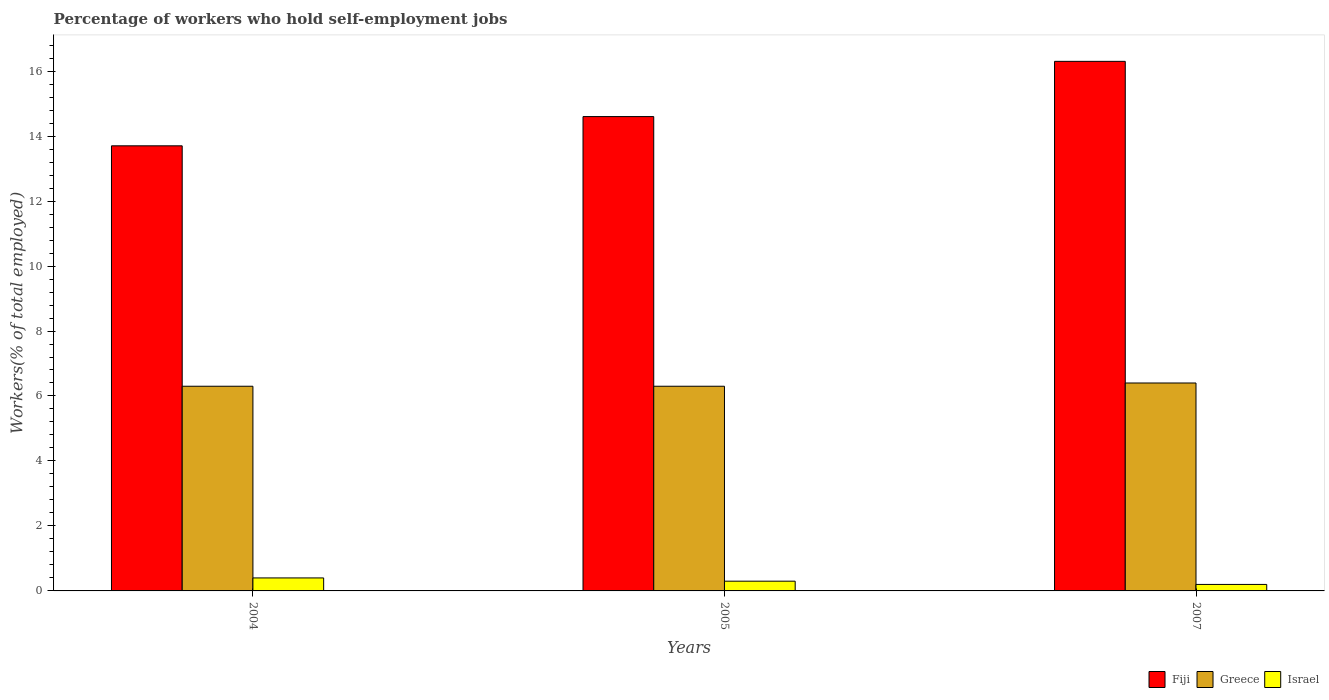How many different coloured bars are there?
Ensure brevity in your answer.  3. Are the number of bars per tick equal to the number of legend labels?
Provide a succinct answer. Yes. Are the number of bars on each tick of the X-axis equal?
Ensure brevity in your answer.  Yes. How many bars are there on the 3rd tick from the left?
Offer a very short reply. 3. What is the label of the 2nd group of bars from the left?
Offer a terse response. 2005. What is the percentage of self-employed workers in Fiji in 2005?
Provide a succinct answer. 14.6. Across all years, what is the maximum percentage of self-employed workers in Israel?
Your response must be concise. 0.4. Across all years, what is the minimum percentage of self-employed workers in Israel?
Provide a succinct answer. 0.2. In which year was the percentage of self-employed workers in Fiji maximum?
Give a very brief answer. 2007. What is the total percentage of self-employed workers in Israel in the graph?
Ensure brevity in your answer.  0.9. What is the difference between the percentage of self-employed workers in Israel in 2005 and that in 2007?
Make the answer very short. 0.1. What is the difference between the percentage of self-employed workers in Greece in 2007 and the percentage of self-employed workers in Israel in 2005?
Provide a succinct answer. 6.1. What is the average percentage of self-employed workers in Greece per year?
Provide a succinct answer. 6.33. In the year 2004, what is the difference between the percentage of self-employed workers in Fiji and percentage of self-employed workers in Greece?
Give a very brief answer. 7.4. What is the ratio of the percentage of self-employed workers in Fiji in 2005 to that in 2007?
Ensure brevity in your answer.  0.9. Is the percentage of self-employed workers in Greece in 2005 less than that in 2007?
Your answer should be compact. Yes. Is the difference between the percentage of self-employed workers in Fiji in 2004 and 2007 greater than the difference between the percentage of self-employed workers in Greece in 2004 and 2007?
Keep it short and to the point. No. What is the difference between the highest and the second highest percentage of self-employed workers in Greece?
Provide a succinct answer. 0.1. What is the difference between the highest and the lowest percentage of self-employed workers in Israel?
Provide a short and direct response. 0.2. Is the sum of the percentage of self-employed workers in Israel in 2004 and 2005 greater than the maximum percentage of self-employed workers in Greece across all years?
Provide a short and direct response. No. What does the 3rd bar from the left in 2007 represents?
Ensure brevity in your answer.  Israel. How many years are there in the graph?
Give a very brief answer. 3. What is the difference between two consecutive major ticks on the Y-axis?
Offer a terse response. 2. Does the graph contain any zero values?
Keep it short and to the point. No. Where does the legend appear in the graph?
Make the answer very short. Bottom right. How many legend labels are there?
Your answer should be compact. 3. How are the legend labels stacked?
Offer a very short reply. Horizontal. What is the title of the graph?
Your answer should be very brief. Percentage of workers who hold self-employment jobs. Does "Sint Maarten (Dutch part)" appear as one of the legend labels in the graph?
Your response must be concise. No. What is the label or title of the Y-axis?
Keep it short and to the point. Workers(% of total employed). What is the Workers(% of total employed) of Fiji in 2004?
Offer a very short reply. 13.7. What is the Workers(% of total employed) of Greece in 2004?
Provide a short and direct response. 6.3. What is the Workers(% of total employed) of Israel in 2004?
Keep it short and to the point. 0.4. What is the Workers(% of total employed) of Fiji in 2005?
Your answer should be compact. 14.6. What is the Workers(% of total employed) in Greece in 2005?
Offer a terse response. 6.3. What is the Workers(% of total employed) in Israel in 2005?
Your response must be concise. 0.3. What is the Workers(% of total employed) in Fiji in 2007?
Offer a terse response. 16.3. What is the Workers(% of total employed) of Greece in 2007?
Make the answer very short. 6.4. What is the Workers(% of total employed) of Israel in 2007?
Ensure brevity in your answer.  0.2. Across all years, what is the maximum Workers(% of total employed) of Fiji?
Provide a short and direct response. 16.3. Across all years, what is the maximum Workers(% of total employed) in Greece?
Keep it short and to the point. 6.4. Across all years, what is the maximum Workers(% of total employed) in Israel?
Your answer should be compact. 0.4. Across all years, what is the minimum Workers(% of total employed) in Fiji?
Provide a succinct answer. 13.7. Across all years, what is the minimum Workers(% of total employed) of Greece?
Provide a succinct answer. 6.3. Across all years, what is the minimum Workers(% of total employed) of Israel?
Keep it short and to the point. 0.2. What is the total Workers(% of total employed) in Fiji in the graph?
Offer a terse response. 44.6. What is the total Workers(% of total employed) in Greece in the graph?
Give a very brief answer. 19. What is the difference between the Workers(% of total employed) in Greece in 2004 and that in 2005?
Provide a succinct answer. 0. What is the difference between the Workers(% of total employed) in Fiji in 2004 and that in 2007?
Offer a very short reply. -2.6. What is the difference between the Workers(% of total employed) in Greece in 2004 and that in 2007?
Provide a succinct answer. -0.1. What is the difference between the Workers(% of total employed) in Israel in 2004 and that in 2007?
Your response must be concise. 0.2. What is the difference between the Workers(% of total employed) of Greece in 2005 and that in 2007?
Offer a terse response. -0.1. What is the difference between the Workers(% of total employed) of Israel in 2005 and that in 2007?
Your answer should be very brief. 0.1. What is the difference between the Workers(% of total employed) of Greece in 2005 and the Workers(% of total employed) of Israel in 2007?
Your answer should be compact. 6.1. What is the average Workers(% of total employed) in Fiji per year?
Give a very brief answer. 14.87. What is the average Workers(% of total employed) in Greece per year?
Offer a terse response. 6.33. What is the average Workers(% of total employed) of Israel per year?
Make the answer very short. 0.3. In the year 2005, what is the difference between the Workers(% of total employed) of Greece and Workers(% of total employed) of Israel?
Make the answer very short. 6. In the year 2007, what is the difference between the Workers(% of total employed) in Fiji and Workers(% of total employed) in Greece?
Make the answer very short. 9.9. In the year 2007, what is the difference between the Workers(% of total employed) in Fiji and Workers(% of total employed) in Israel?
Keep it short and to the point. 16.1. In the year 2007, what is the difference between the Workers(% of total employed) of Greece and Workers(% of total employed) of Israel?
Your answer should be compact. 6.2. What is the ratio of the Workers(% of total employed) of Fiji in 2004 to that in 2005?
Offer a terse response. 0.94. What is the ratio of the Workers(% of total employed) in Greece in 2004 to that in 2005?
Offer a very short reply. 1. What is the ratio of the Workers(% of total employed) of Israel in 2004 to that in 2005?
Offer a very short reply. 1.33. What is the ratio of the Workers(% of total employed) of Fiji in 2004 to that in 2007?
Provide a succinct answer. 0.84. What is the ratio of the Workers(% of total employed) in Greece in 2004 to that in 2007?
Provide a succinct answer. 0.98. What is the ratio of the Workers(% of total employed) in Israel in 2004 to that in 2007?
Provide a short and direct response. 2. What is the ratio of the Workers(% of total employed) of Fiji in 2005 to that in 2007?
Offer a very short reply. 0.9. What is the ratio of the Workers(% of total employed) of Greece in 2005 to that in 2007?
Keep it short and to the point. 0.98. What is the difference between the highest and the lowest Workers(% of total employed) of Greece?
Keep it short and to the point. 0.1. What is the difference between the highest and the lowest Workers(% of total employed) in Israel?
Offer a very short reply. 0.2. 